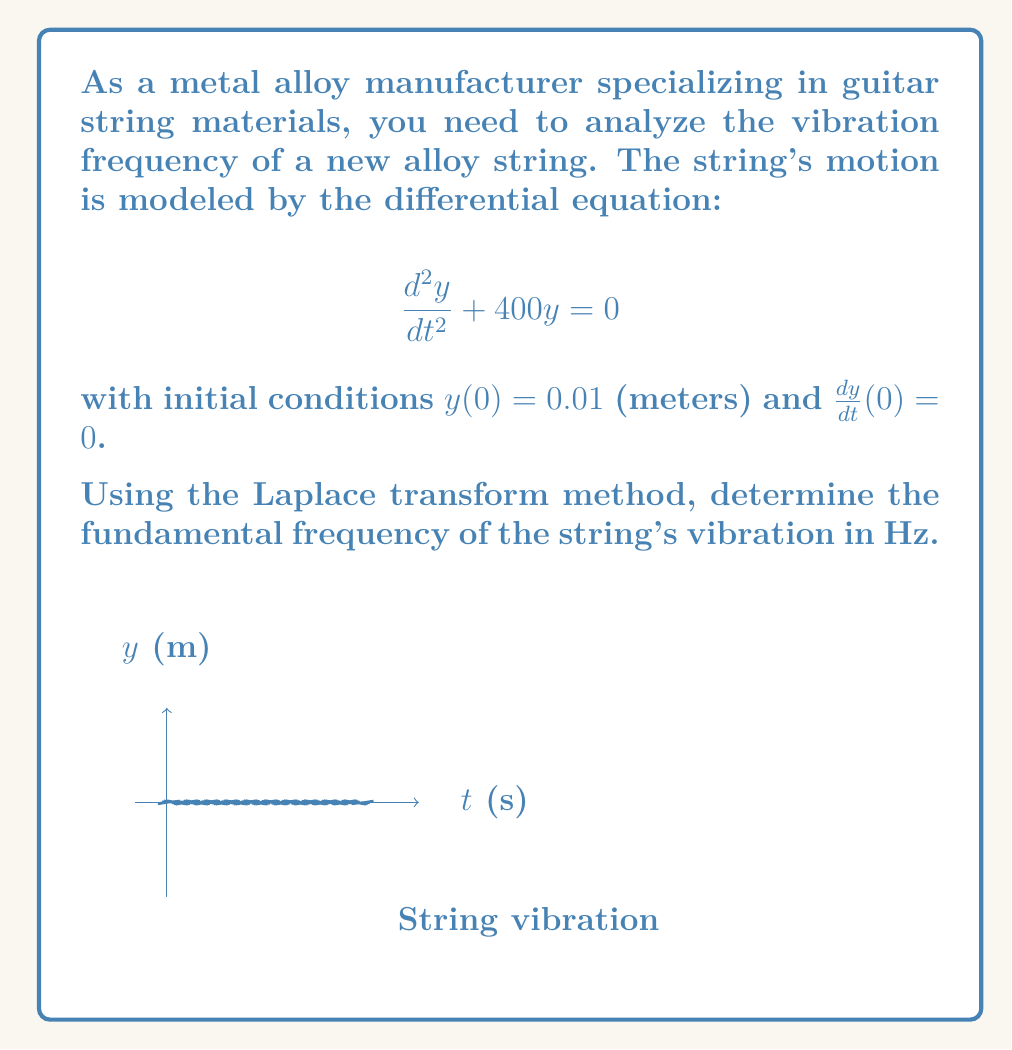Teach me how to tackle this problem. Let's solve this step-by-step using the Laplace transform:

1) Take the Laplace transform of both sides of the equation:
   $$\mathcal{L}\left\{\frac{d^2y}{dt^2} + 400y\right\} = \mathcal{L}\{0\}$$

2) Using Laplace transform properties:
   $$s^2Y(s) - sy(0) - y'(0) + 400Y(s) = 0$$

3) Substitute the initial conditions:
   $$s^2Y(s) - s(0.01) - 0 + 400Y(s) = 0$$

4) Simplify:
   $$(s^2 + 400)Y(s) = 0.01s$$

5) Solve for Y(s):
   $$Y(s) = \frac{0.01s}{s^2 + 400}$$

6) This is in the form of:
   $$Y(s) = \frac{0.01s}{s^2 + 20^2}$$

7) The inverse Laplace transform of this form is:
   $$y(t) = 0.01\sin(20t)$$

8) The angular frequency ω is 20 rad/s.

9) Convert to Hz using the formula $f = \frac{\omega}{2\pi}$:
   $$f = \frac{20}{2\pi} ≈ 3.18 \text{ Hz}$$

Thus, the fundamental frequency of the string's vibration is approximately 3.18 Hz.
Answer: 3.18 Hz 